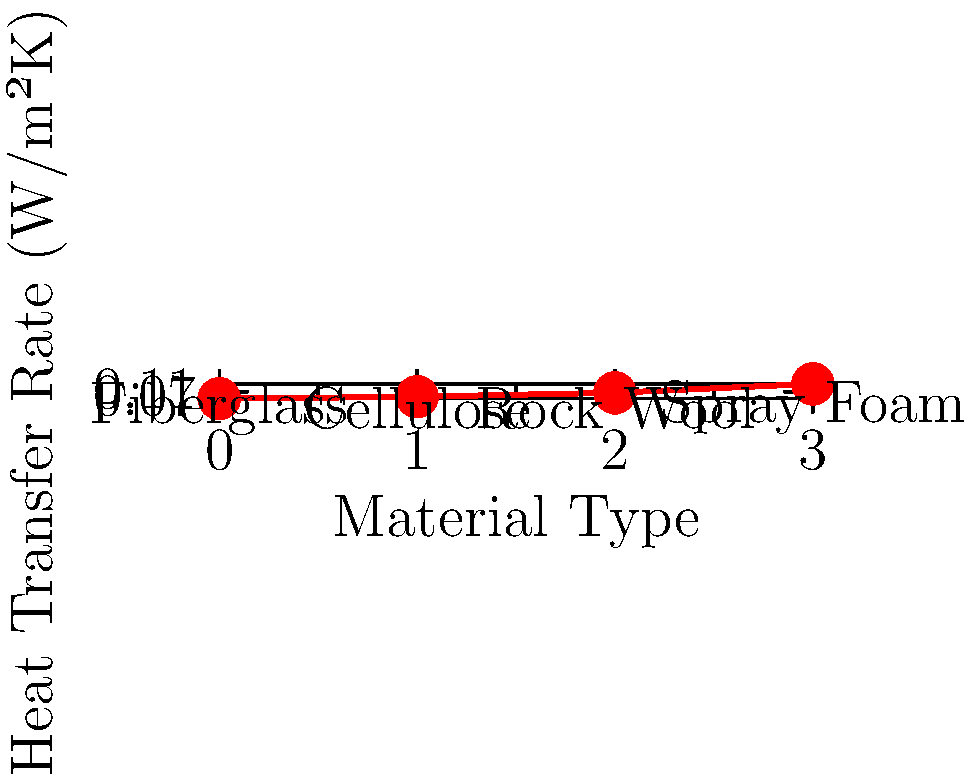As a community organizer working on improving housing conditions in Washington, D.C., you're advocating for better insulation in buildings to reduce energy costs. Based on the graph showing heat transfer rates for different insulation materials, which material would you recommend for the most energy-efficient solution, and why? To determine the most energy-efficient insulation material, we need to analyze the heat transfer rates shown in the graph. The heat transfer rate is measured in W/m²K (Watts per square meter per Kelvin), which represents the rate of heat loss through a material. A lower heat transfer rate indicates better insulation performance.

Let's examine the heat transfer rates for each material:

1. Fiberglass: 0.035 W/m²K
2. Cellulose: 0.045 W/m²K
3. Rock Wool: 0.065 W/m²K
4. Spray Foam: 0.11 W/m²K

The material with the lowest heat transfer rate will provide the best insulation and be the most energy-efficient. In this case, fiberglass has the lowest heat transfer rate at 0.035 W/m²K.

To understand why fiberglass is the most energy-efficient:

1. Lower heat transfer rate means less heat loss through the material.
2. Less heat loss leads to better temperature regulation inside buildings.
3. Better temperature regulation results in reduced energy consumption for heating and cooling.
4. Reduced energy consumption leads to lower energy costs for residents.
5. Lower energy costs contribute to improved quality of life and affordability for community members.

As a community organizer, recommending fiberglass insulation would help achieve the goal of improving housing conditions and reducing energy costs for residents in Washington, D.C.
Answer: Fiberglass, due to its lowest heat transfer rate of 0.035 W/m²K. 